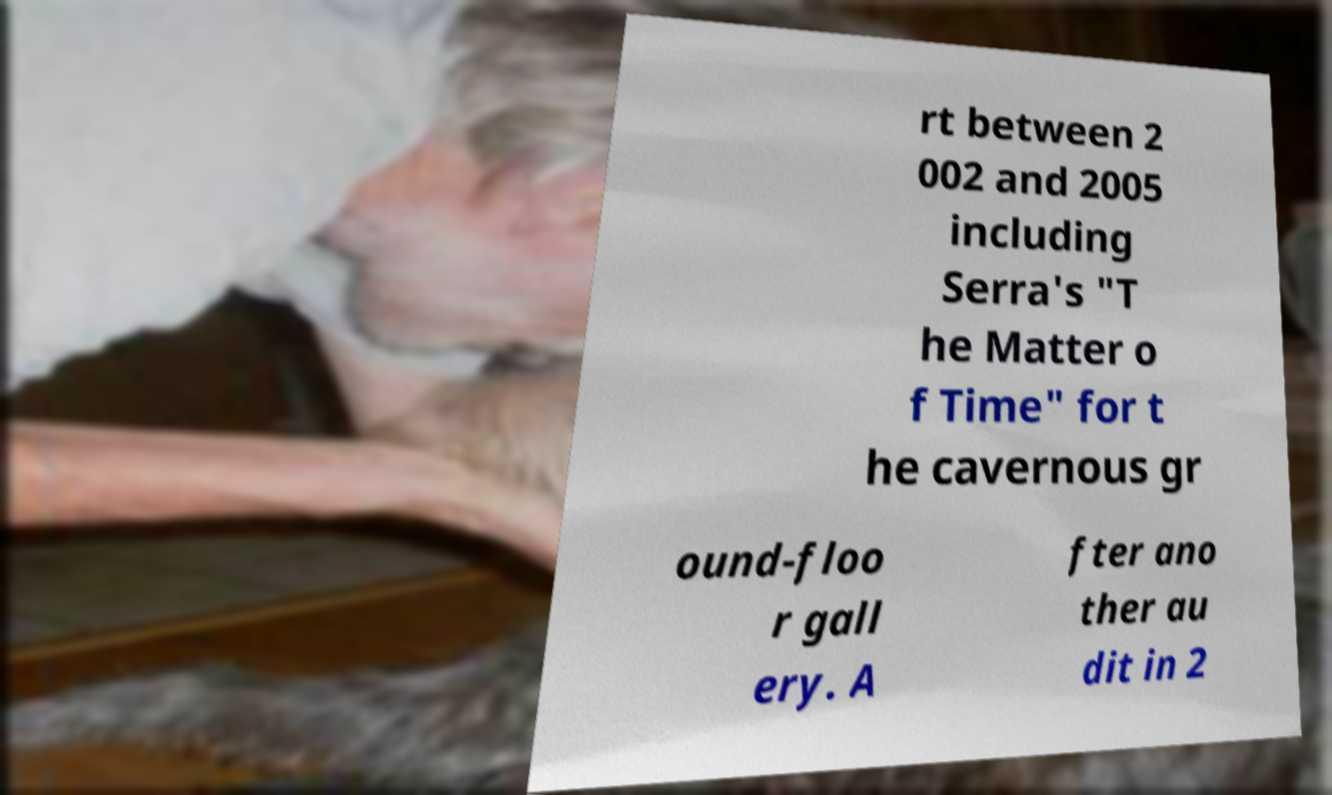What messages or text are displayed in this image? I need them in a readable, typed format. rt between 2 002 and 2005 including Serra's "T he Matter o f Time" for t he cavernous gr ound-floo r gall ery. A fter ano ther au dit in 2 